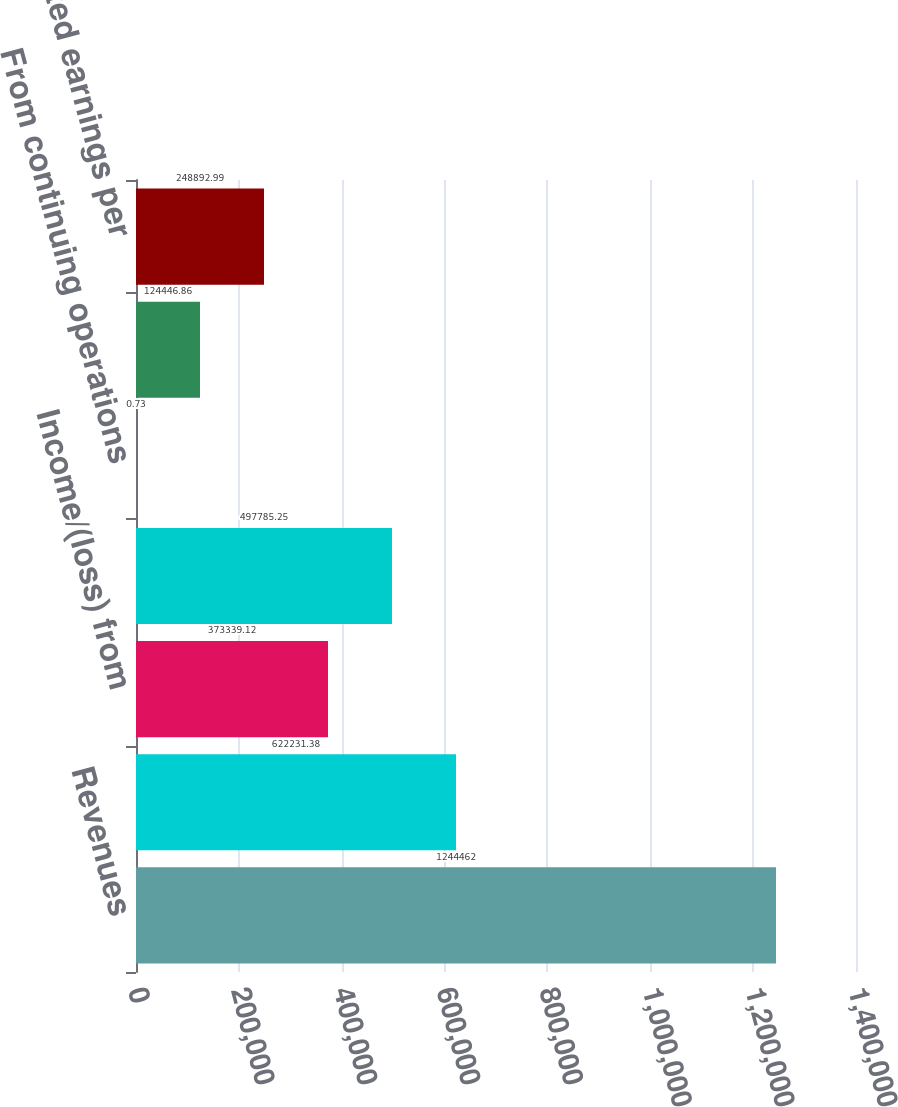Convert chart. <chart><loc_0><loc_0><loc_500><loc_500><bar_chart><fcel>Revenues<fcel>Income from continuing<fcel>Income/(loss) from<fcel>Net income<fcel>From continuing operations<fcel>Total basic earnings per share<fcel>Total diluted earnings per<nl><fcel>1.24446e+06<fcel>622231<fcel>373339<fcel>497785<fcel>0.73<fcel>124447<fcel>248893<nl></chart> 